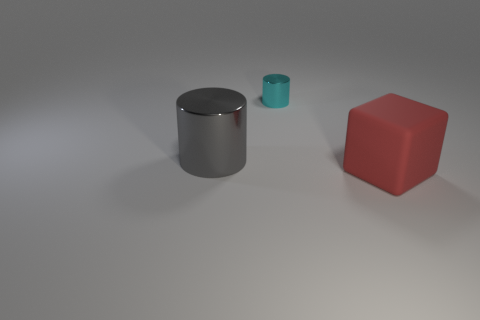Are there any other things that are made of the same material as the large red cube?
Provide a short and direct response. No. There is a thing that is the same size as the red block; what shape is it?
Provide a short and direct response. Cylinder. The gray cylinder that is made of the same material as the cyan cylinder is what size?
Offer a very short reply. Large. Do the large shiny object and the metal object behind the gray metal cylinder have the same shape?
Your response must be concise. Yes. How big is the cyan thing?
Provide a short and direct response. Small. Is the number of cyan things on the left side of the large red rubber block less than the number of red matte blocks?
Your response must be concise. No. What number of gray cylinders have the same size as the cube?
Make the answer very short. 1. How many red blocks are in front of the large red rubber block?
Keep it short and to the point. 0. Are there any other small things of the same shape as the gray metallic object?
Keep it short and to the point. Yes. What is the color of the other thing that is the same size as the gray shiny object?
Provide a short and direct response. Red. 